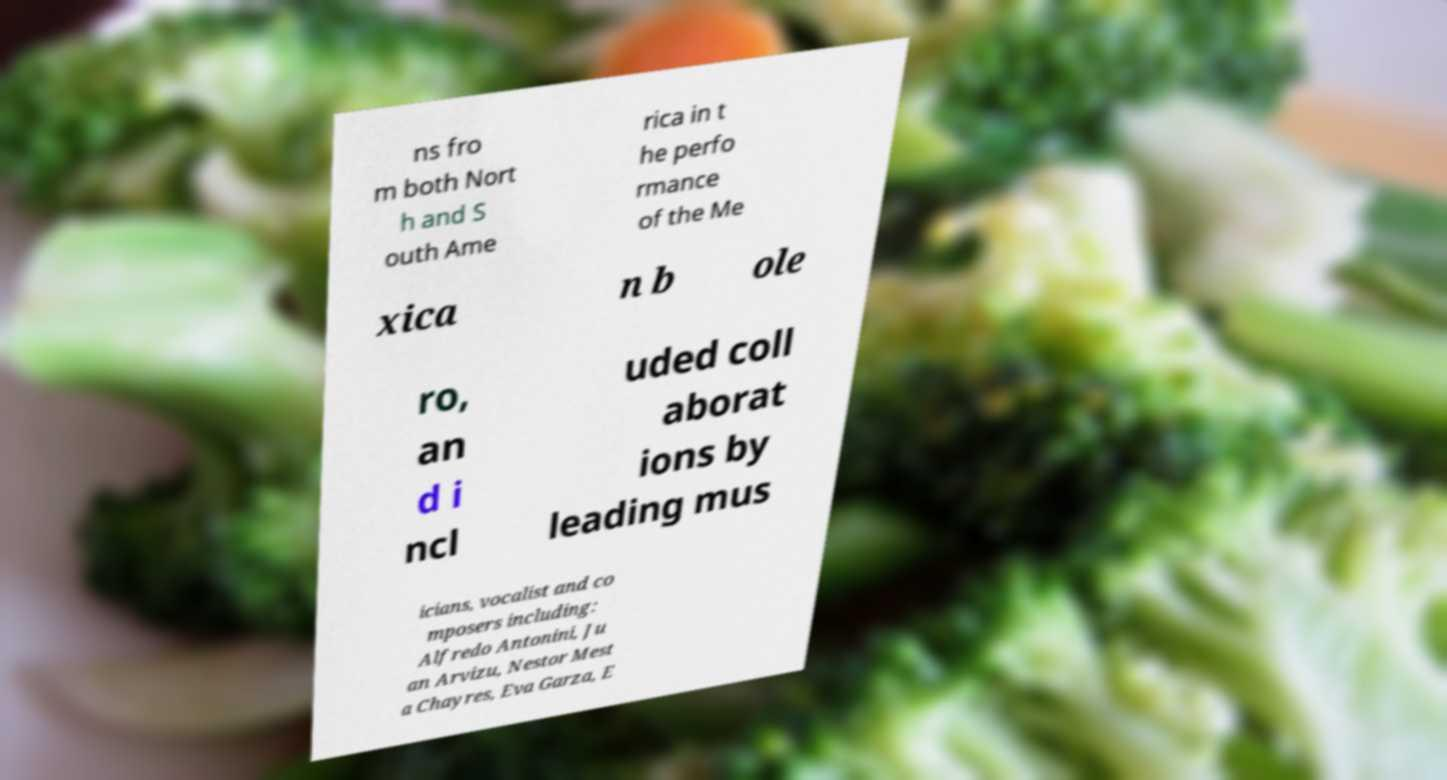I need the written content from this picture converted into text. Can you do that? ns fro m both Nort h and S outh Ame rica in t he perfo rmance of the Me xica n b ole ro, an d i ncl uded coll aborat ions by leading mus icians, vocalist and co mposers including: Alfredo Antonini, Ju an Arvizu, Nestor Mest a Chayres, Eva Garza, E 